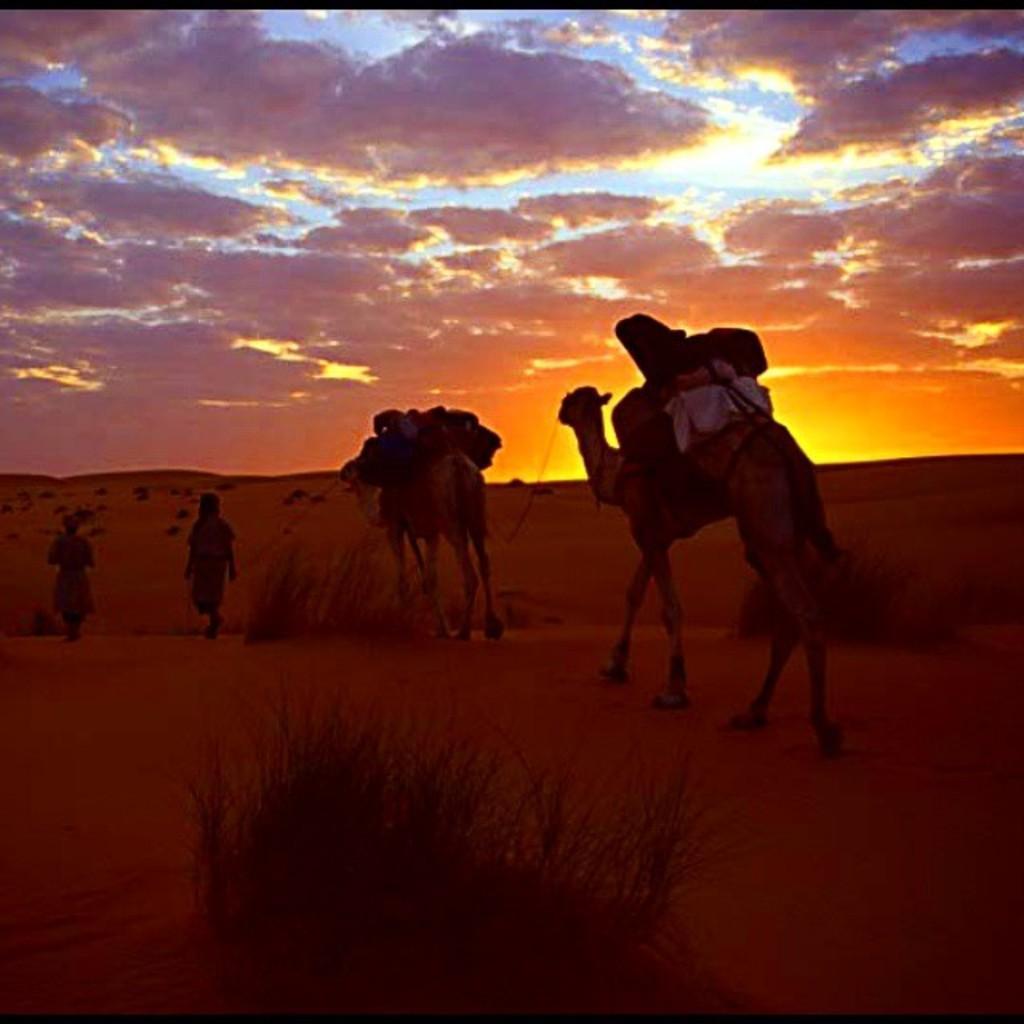Could you give a brief overview of what you see in this image? In this picture we can observe camels walking in the desert. There are two persons walking on the left side. We can observe some plants in the desert. In the background there is a sky with some clouds. 